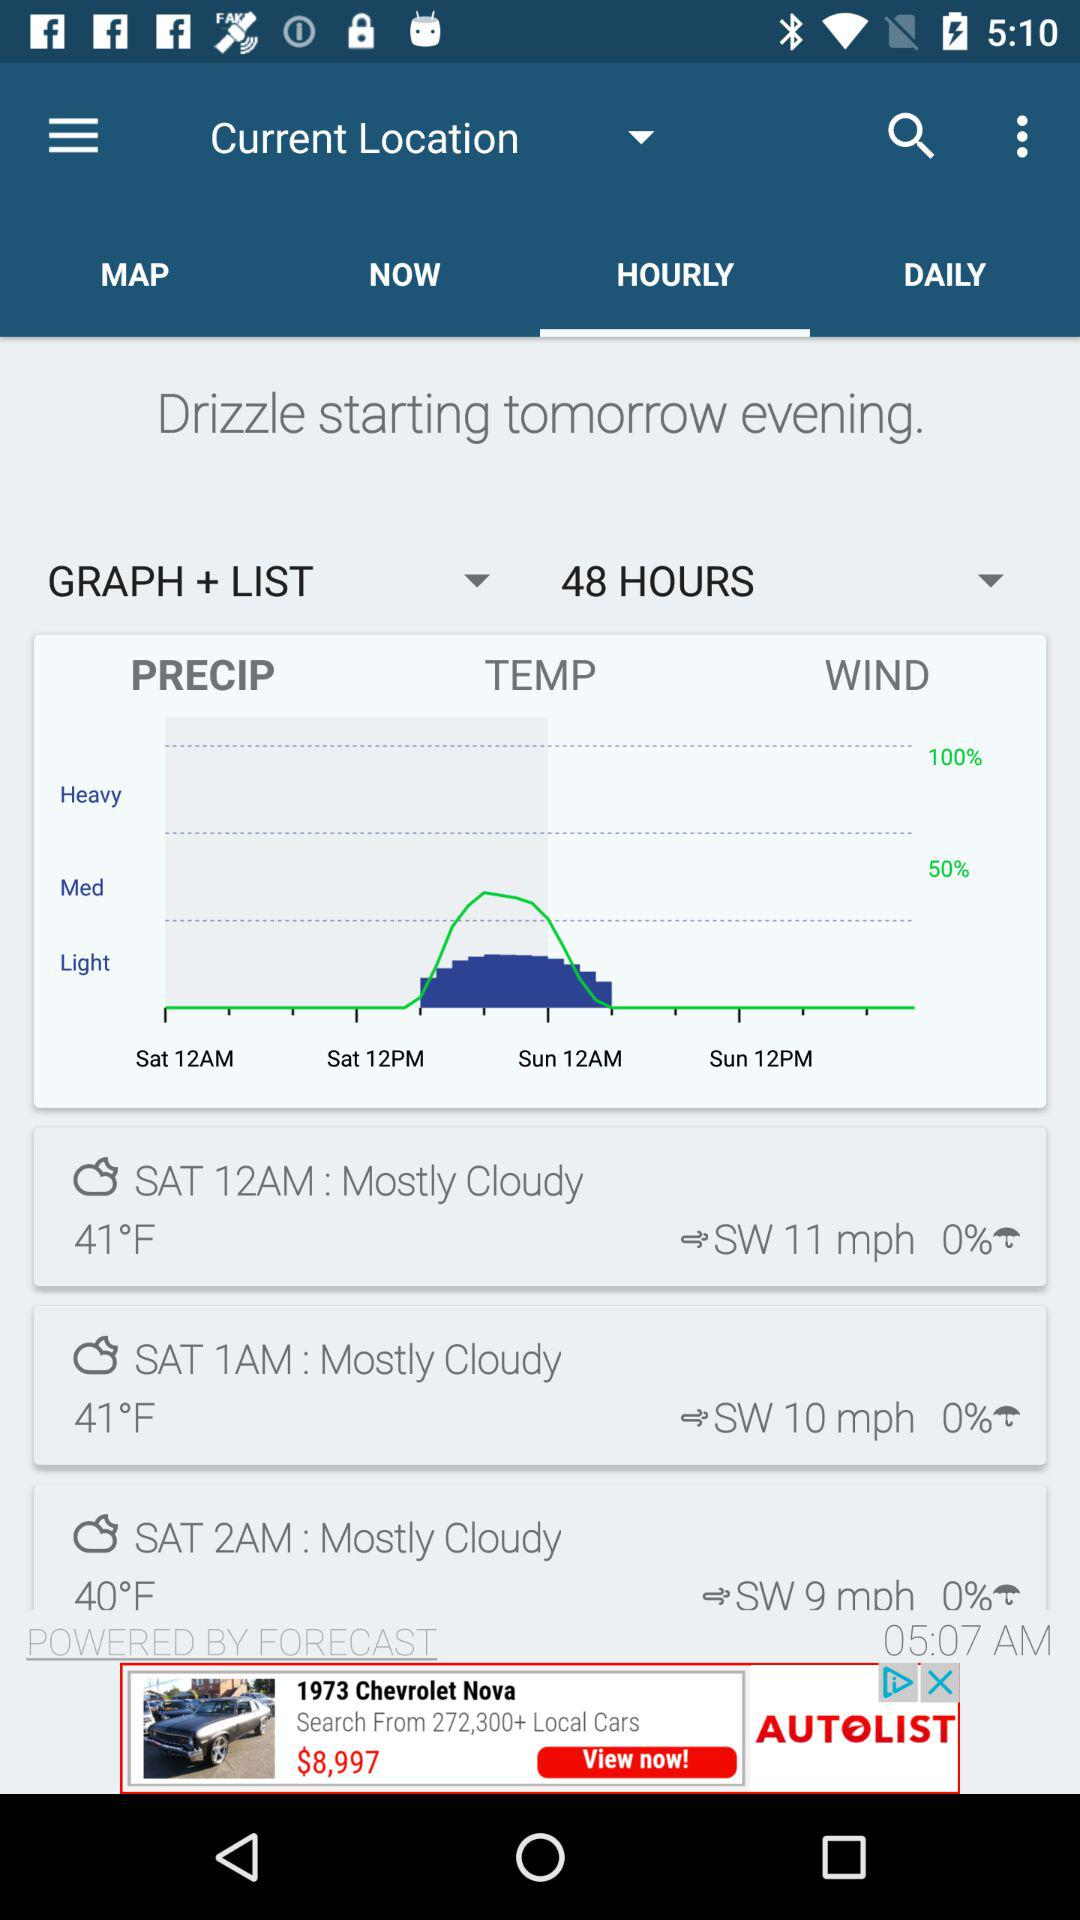How many hours are in the forecast?
Answer the question using a single word or phrase. 48 